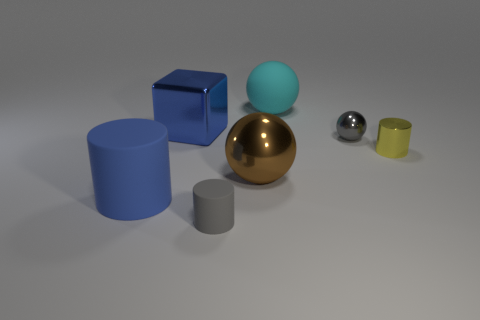How many matte objects are either cyan things or green things?
Provide a short and direct response. 1. What is the shape of the small thing that is the same color as the tiny rubber cylinder?
Provide a succinct answer. Sphere. How many cyan objects are there?
Your response must be concise. 1. Do the small gray thing that is in front of the brown metal sphere and the tiny cylinder to the right of the small gray metallic thing have the same material?
Give a very brief answer. No. The cylinder that is made of the same material as the tiny gray ball is what size?
Keep it short and to the point. Small. The small gray object on the right side of the cyan ball has what shape?
Your answer should be compact. Sphere. Does the tiny object left of the tiny metallic ball have the same color as the shiny ball to the right of the large brown thing?
Your answer should be very brief. Yes. There is a matte cylinder that is the same color as the block; what size is it?
Provide a short and direct response. Large. Is there a tiny gray rubber ball?
Offer a terse response. No. There is a matte object to the right of the gray object that is in front of the big matte object in front of the large cyan matte ball; what is its shape?
Provide a succinct answer. Sphere. 